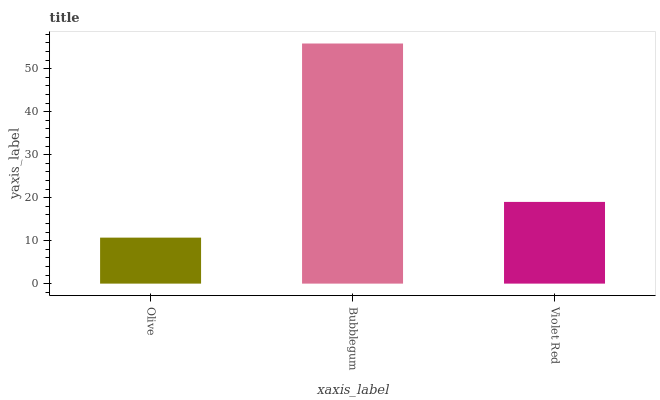Is Olive the minimum?
Answer yes or no. Yes. Is Bubblegum the maximum?
Answer yes or no. Yes. Is Violet Red the minimum?
Answer yes or no. No. Is Violet Red the maximum?
Answer yes or no. No. Is Bubblegum greater than Violet Red?
Answer yes or no. Yes. Is Violet Red less than Bubblegum?
Answer yes or no. Yes. Is Violet Red greater than Bubblegum?
Answer yes or no. No. Is Bubblegum less than Violet Red?
Answer yes or no. No. Is Violet Red the high median?
Answer yes or no. Yes. Is Violet Red the low median?
Answer yes or no. Yes. Is Olive the high median?
Answer yes or no. No. Is Olive the low median?
Answer yes or no. No. 